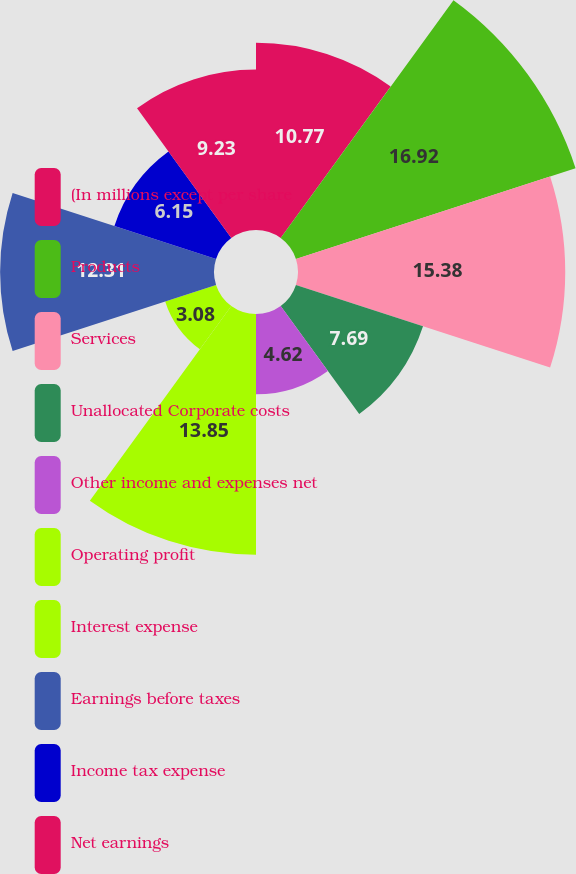Convert chart. <chart><loc_0><loc_0><loc_500><loc_500><pie_chart><fcel>(In millions except per share<fcel>Products<fcel>Services<fcel>Unallocated Corporate costs<fcel>Other income and expenses net<fcel>Operating profit<fcel>Interest expense<fcel>Earnings before taxes<fcel>Income tax expense<fcel>Net earnings<nl><fcel>10.77%<fcel>16.92%<fcel>15.38%<fcel>7.69%<fcel>4.62%<fcel>13.85%<fcel>3.08%<fcel>12.31%<fcel>6.15%<fcel>9.23%<nl></chart> 